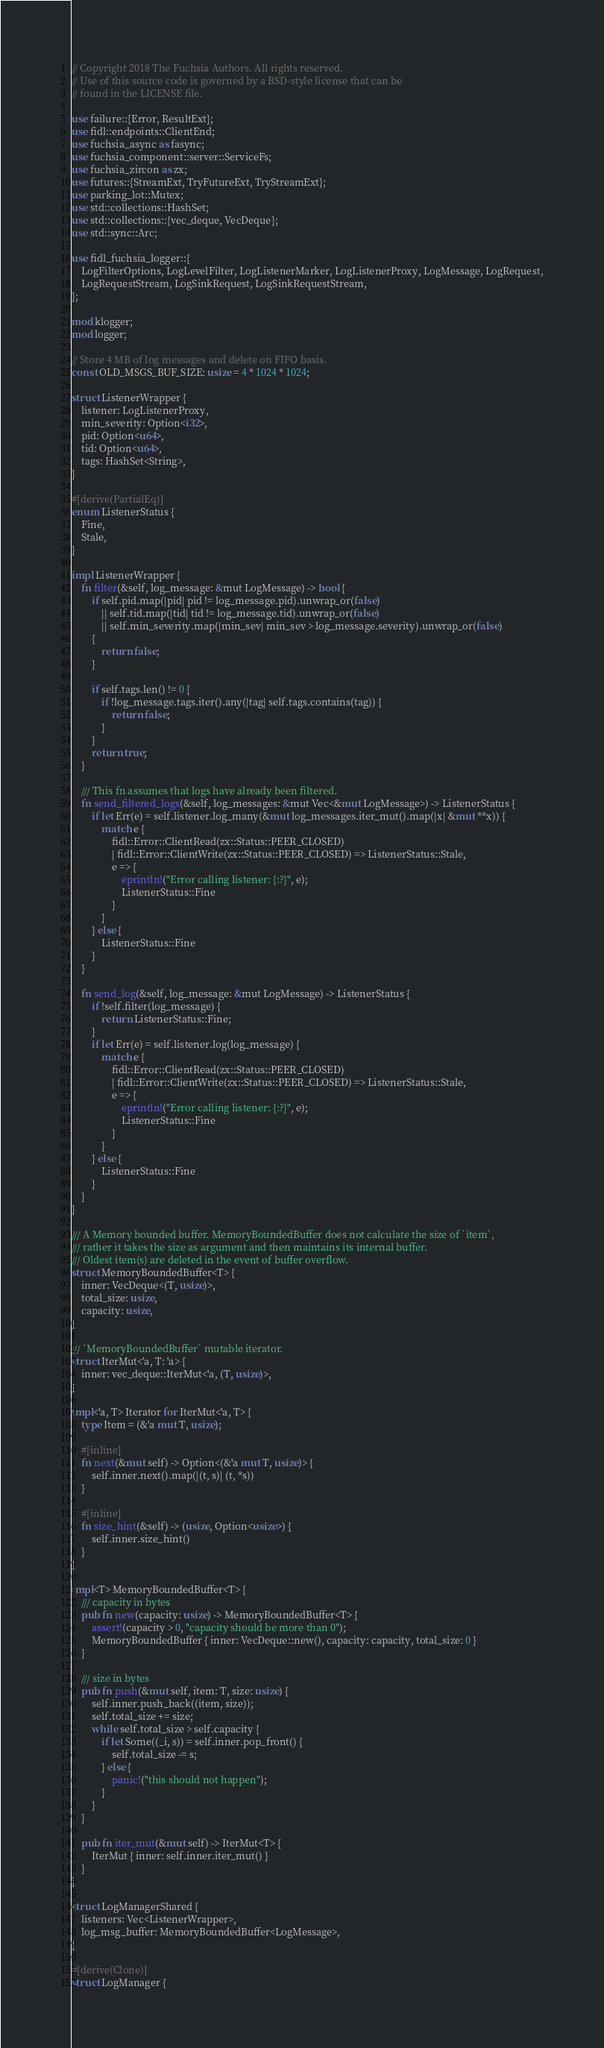<code> <loc_0><loc_0><loc_500><loc_500><_Rust_>// Copyright 2018 The Fuchsia Authors. All rights reserved.
// Use of this source code is governed by a BSD-style license that can be
// found in the LICENSE file.

use failure::{Error, ResultExt};
use fidl::endpoints::ClientEnd;
use fuchsia_async as fasync;
use fuchsia_component::server::ServiceFs;
use fuchsia_zircon as zx;
use futures::{StreamExt, TryFutureExt, TryStreamExt};
use parking_lot::Mutex;
use std::collections::HashSet;
use std::collections::{vec_deque, VecDeque};
use std::sync::Arc;

use fidl_fuchsia_logger::{
    LogFilterOptions, LogLevelFilter, LogListenerMarker, LogListenerProxy, LogMessage, LogRequest,
    LogRequestStream, LogSinkRequest, LogSinkRequestStream,
};

mod klogger;
mod logger;

// Store 4 MB of log messages and delete on FIFO basis.
const OLD_MSGS_BUF_SIZE: usize = 4 * 1024 * 1024;

struct ListenerWrapper {
    listener: LogListenerProxy,
    min_severity: Option<i32>,
    pid: Option<u64>,
    tid: Option<u64>,
    tags: HashSet<String>,
}

#[derive(PartialEq)]
enum ListenerStatus {
    Fine,
    Stale,
}

impl ListenerWrapper {
    fn filter(&self, log_message: &mut LogMessage) -> bool {
        if self.pid.map(|pid| pid != log_message.pid).unwrap_or(false)
            || self.tid.map(|tid| tid != log_message.tid).unwrap_or(false)
            || self.min_severity.map(|min_sev| min_sev > log_message.severity).unwrap_or(false)
        {
            return false;
        }

        if self.tags.len() != 0 {
            if !log_message.tags.iter().any(|tag| self.tags.contains(tag)) {
                return false;
            }
        }
        return true;
    }

    /// This fn assumes that logs have already been filtered.
    fn send_filtered_logs(&self, log_messages: &mut Vec<&mut LogMessage>) -> ListenerStatus {
        if let Err(e) = self.listener.log_many(&mut log_messages.iter_mut().map(|x| &mut **x)) {
            match e {
                fidl::Error::ClientRead(zx::Status::PEER_CLOSED)
                | fidl::Error::ClientWrite(zx::Status::PEER_CLOSED) => ListenerStatus::Stale,
                e => {
                    eprintln!("Error calling listener: {:?}", e);
                    ListenerStatus::Fine
                }
            }
        } else {
            ListenerStatus::Fine
        }
    }

    fn send_log(&self, log_message: &mut LogMessage) -> ListenerStatus {
        if !self.filter(log_message) {
            return ListenerStatus::Fine;
        }
        if let Err(e) = self.listener.log(log_message) {
            match e {
                fidl::Error::ClientRead(zx::Status::PEER_CLOSED)
                | fidl::Error::ClientWrite(zx::Status::PEER_CLOSED) => ListenerStatus::Stale,
                e => {
                    eprintln!("Error calling listener: {:?}", e);
                    ListenerStatus::Fine
                }
            }
        } else {
            ListenerStatus::Fine
        }
    }
}

/// A Memory bounded buffer. MemoryBoundedBuffer does not calculate the size of `item`,
/// rather it takes the size as argument and then maintains its internal buffer.
/// Oldest item(s) are deleted in the event of buffer overflow.
struct MemoryBoundedBuffer<T> {
    inner: VecDeque<(T, usize)>,
    total_size: usize,
    capacity: usize,
}

/// `MemoryBoundedBuffer` mutable iterator.
struct IterMut<'a, T: 'a> {
    inner: vec_deque::IterMut<'a, (T, usize)>,
}

impl<'a, T> Iterator for IterMut<'a, T> {
    type Item = (&'a mut T, usize);

    #[inline]
    fn next(&mut self) -> Option<(&'a mut T, usize)> {
        self.inner.next().map(|(t, s)| (t, *s))
    }

    #[inline]
    fn size_hint(&self) -> (usize, Option<usize>) {
        self.inner.size_hint()
    }
}

impl<T> MemoryBoundedBuffer<T> {
    /// capacity in bytes
    pub fn new(capacity: usize) -> MemoryBoundedBuffer<T> {
        assert!(capacity > 0, "capacity should be more than 0");
        MemoryBoundedBuffer { inner: VecDeque::new(), capacity: capacity, total_size: 0 }
    }

    /// size in bytes
    pub fn push(&mut self, item: T, size: usize) {
        self.inner.push_back((item, size));
        self.total_size += size;
        while self.total_size > self.capacity {
            if let Some((_i, s)) = self.inner.pop_front() {
                self.total_size -= s;
            } else {
                panic!("this should not happen");
            }
        }
    }

    pub fn iter_mut(&mut self) -> IterMut<T> {
        IterMut { inner: self.inner.iter_mut() }
    }
}

struct LogManagerShared {
    listeners: Vec<ListenerWrapper>,
    log_msg_buffer: MemoryBoundedBuffer<LogMessage>,
}

#[derive(Clone)]
struct LogManager {</code> 